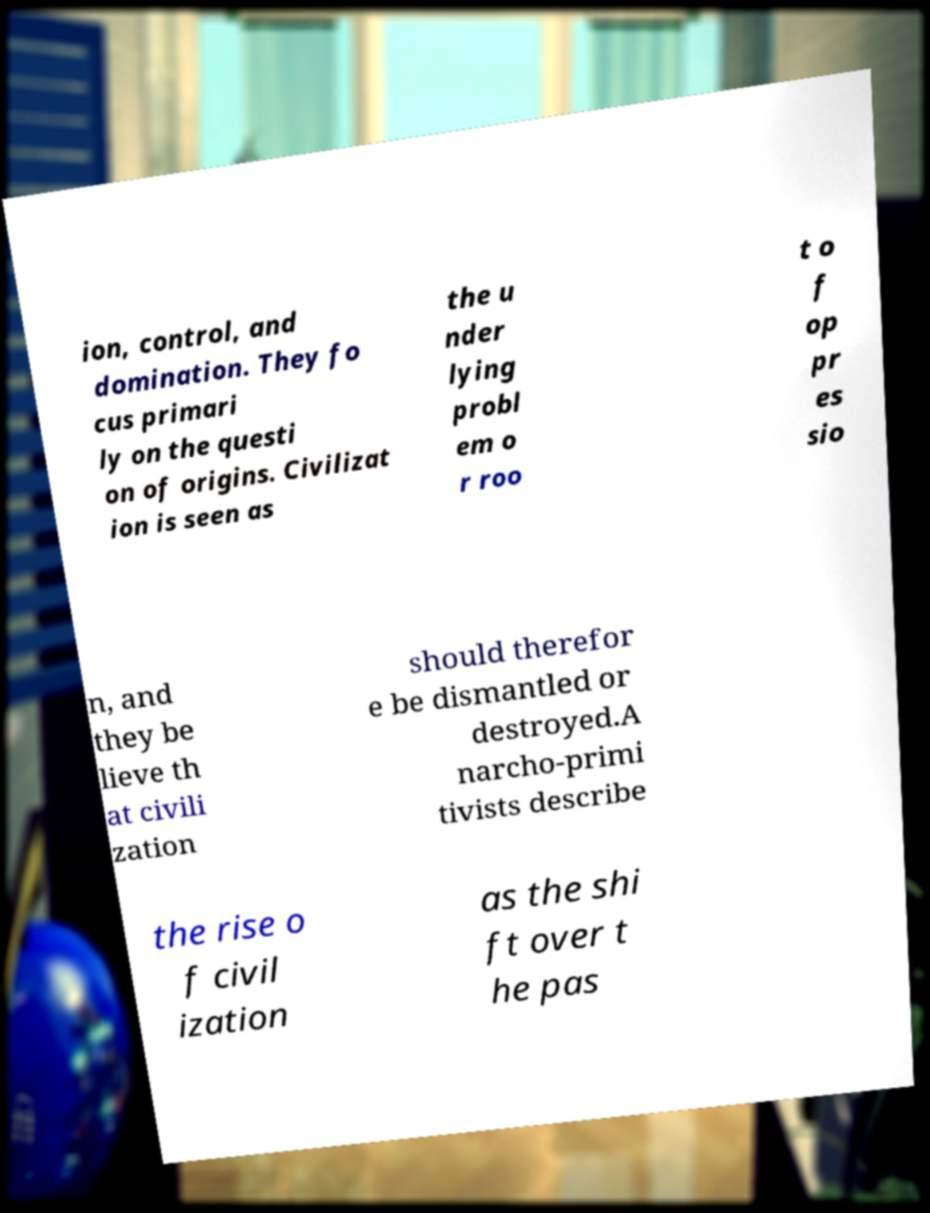Can you accurately transcribe the text from the provided image for me? ion, control, and domination. They fo cus primari ly on the questi on of origins. Civilizat ion is seen as the u nder lying probl em o r roo t o f op pr es sio n, and they be lieve th at civili zation should therefor e be dismantled or destroyed.A narcho-primi tivists describe the rise o f civil ization as the shi ft over t he pas 